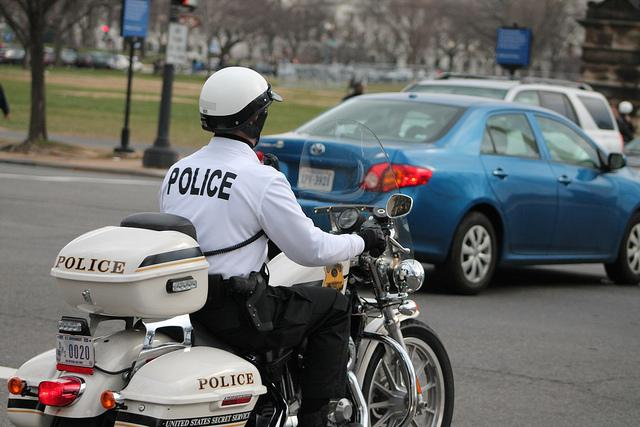The Harley police bikes are iconic bikes of police force in? secret service 